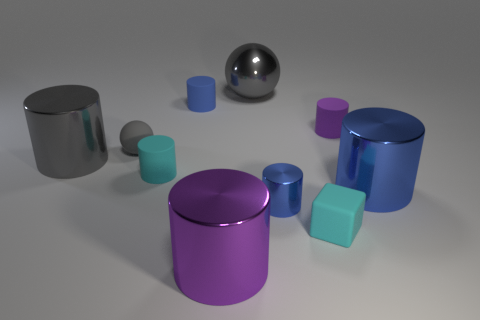Subtract all blue cylinders. How many were subtracted if there are1blue cylinders left? 2 Subtract all large gray metal cylinders. How many cylinders are left? 6 Subtract all cyan cylinders. How many cylinders are left? 6 Subtract 7 cylinders. How many cylinders are left? 0 Subtract all cubes. How many objects are left? 9 Subtract all brown cylinders. Subtract all brown balls. How many cylinders are left? 7 Subtract all yellow spheres. How many gray cylinders are left? 1 Subtract all gray things. Subtract all big cylinders. How many objects are left? 4 Add 5 small cyan cylinders. How many small cyan cylinders are left? 6 Add 5 small blue shiny cylinders. How many small blue shiny cylinders exist? 6 